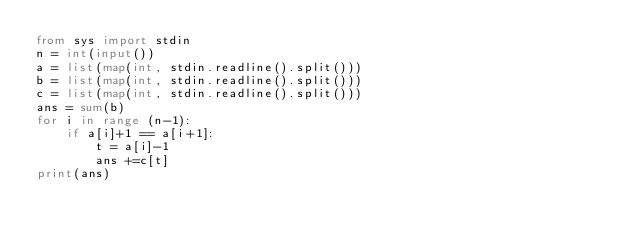Convert code to text. <code><loc_0><loc_0><loc_500><loc_500><_Python_>from sys import stdin
n = int(input())
a = list(map(int, stdin.readline().split()))
b = list(map(int, stdin.readline().split()))
c = list(map(int, stdin.readline().split()))
ans = sum(b)
for i in range (n-1):
    if a[i]+1 == a[i+1]:
        t = a[i]-1
        ans +=c[t]
print(ans)
</code> 